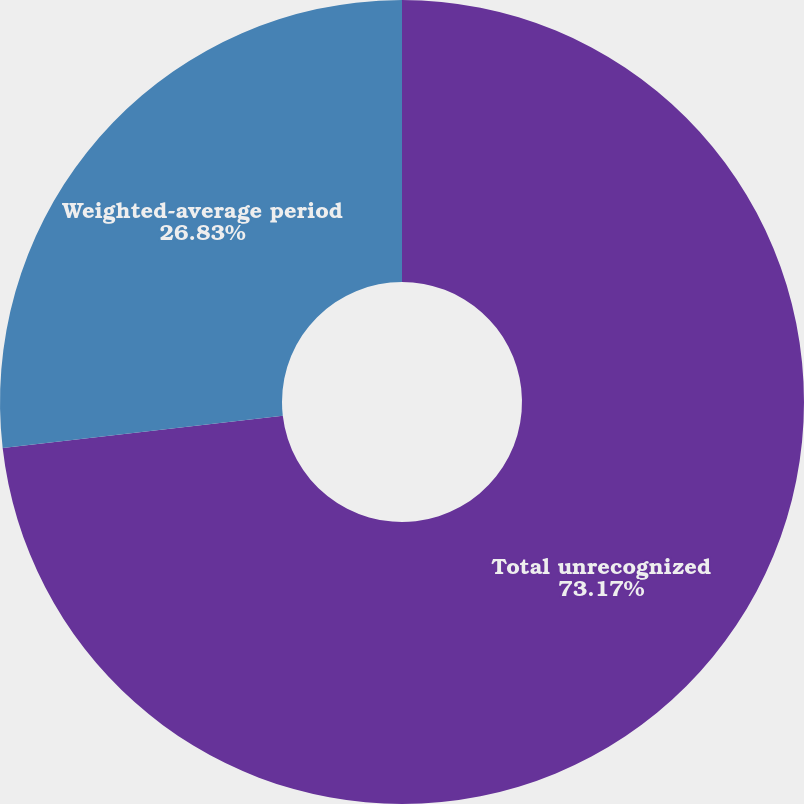<chart> <loc_0><loc_0><loc_500><loc_500><pie_chart><fcel>Total unrecognized<fcel>Weighted-average period<nl><fcel>73.17%<fcel>26.83%<nl></chart> 